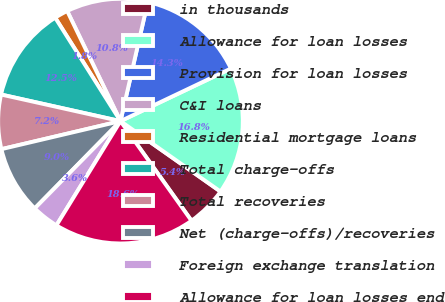Convert chart to OTSL. <chart><loc_0><loc_0><loc_500><loc_500><pie_chart><fcel>in thousands<fcel>Allowance for loan losses<fcel>Provision for loan losses<fcel>C&I loans<fcel>Residential mortgage loans<fcel>Total charge-offs<fcel>Total recoveries<fcel>Net (charge-offs)/recoveries<fcel>Foreign exchange translation<fcel>Allowance for loan losses end<nl><fcel>5.38%<fcel>16.84%<fcel>14.34%<fcel>10.76%<fcel>1.79%<fcel>12.55%<fcel>7.17%<fcel>8.96%<fcel>3.59%<fcel>18.63%<nl></chart> 